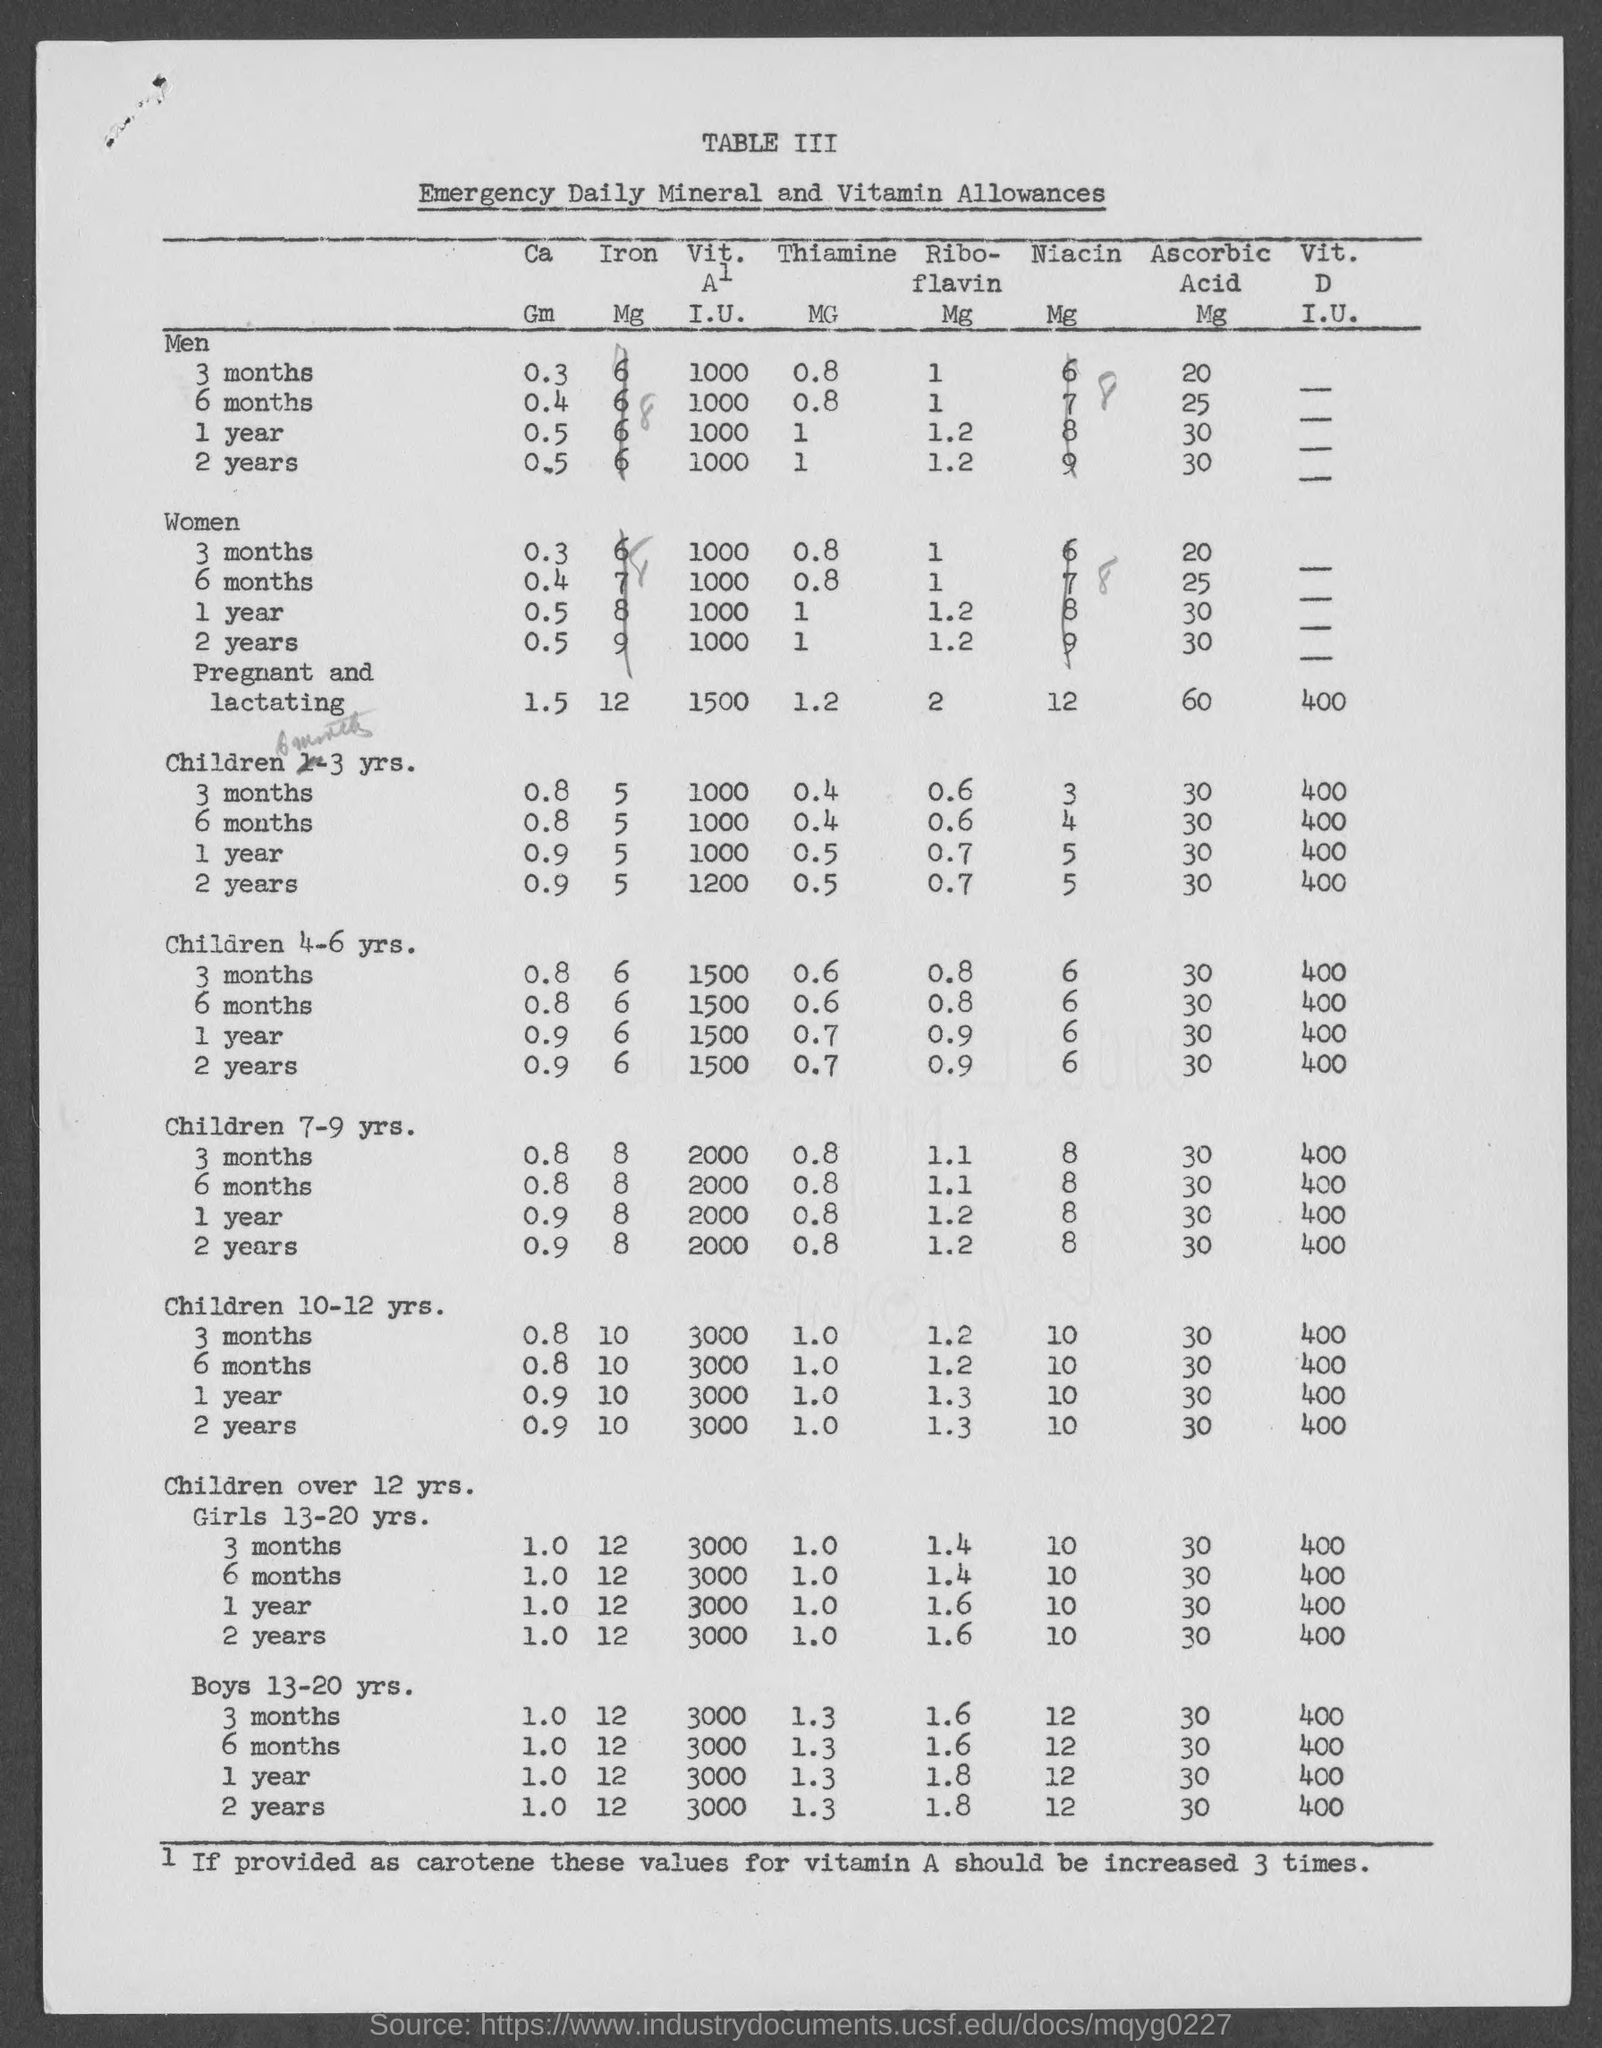Point out several critical features in this image. The daily allowances of emergency substances, as well as the mineral and vitamin allowances, are listed in this table. The value for children aged 7-9 years who have been taking 'Ribo-' for 6 months is 1.1. The value for men for 3 months under the "Ca" category is 0.3. The value for women for 2 years under "Riboflavin" is 1.2. The value for Children 4-6 yrs. for 6 months under "Ca" is 0.8. 